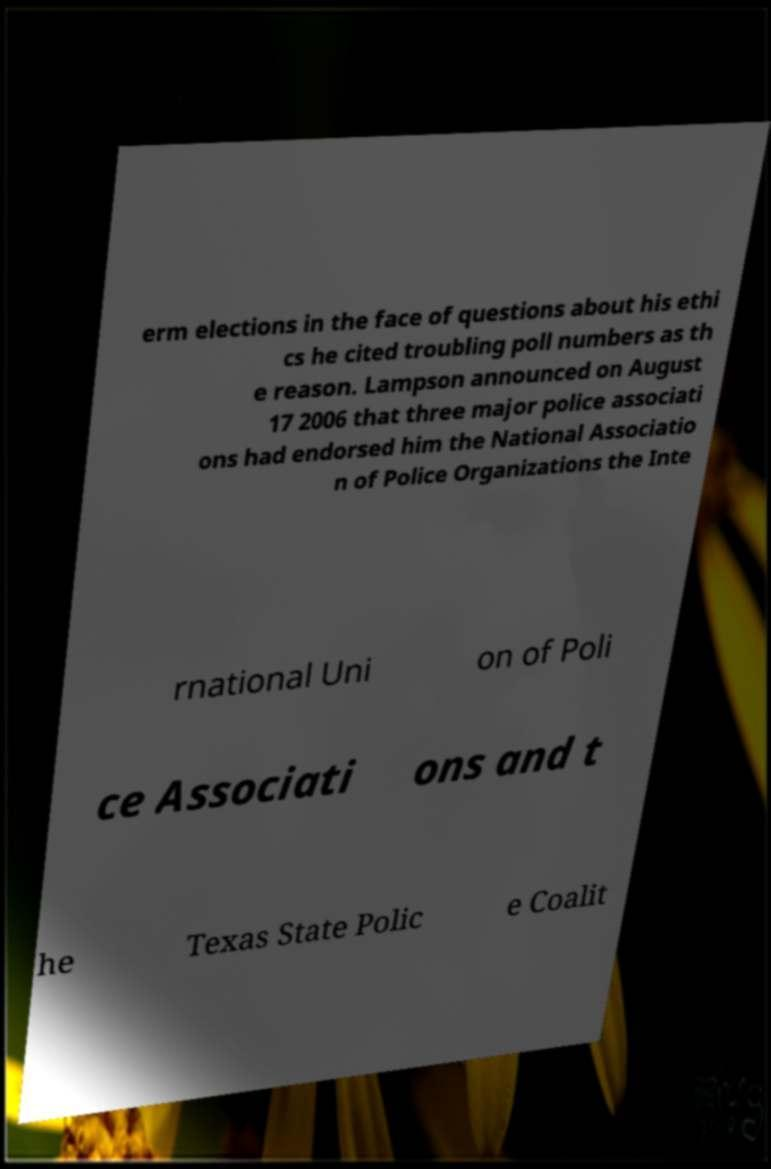For documentation purposes, I need the text within this image transcribed. Could you provide that? erm elections in the face of questions about his ethi cs he cited troubling poll numbers as th e reason. Lampson announced on August 17 2006 that three major police associati ons had endorsed him the National Associatio n of Police Organizations the Inte rnational Uni on of Poli ce Associati ons and t he Texas State Polic e Coalit 